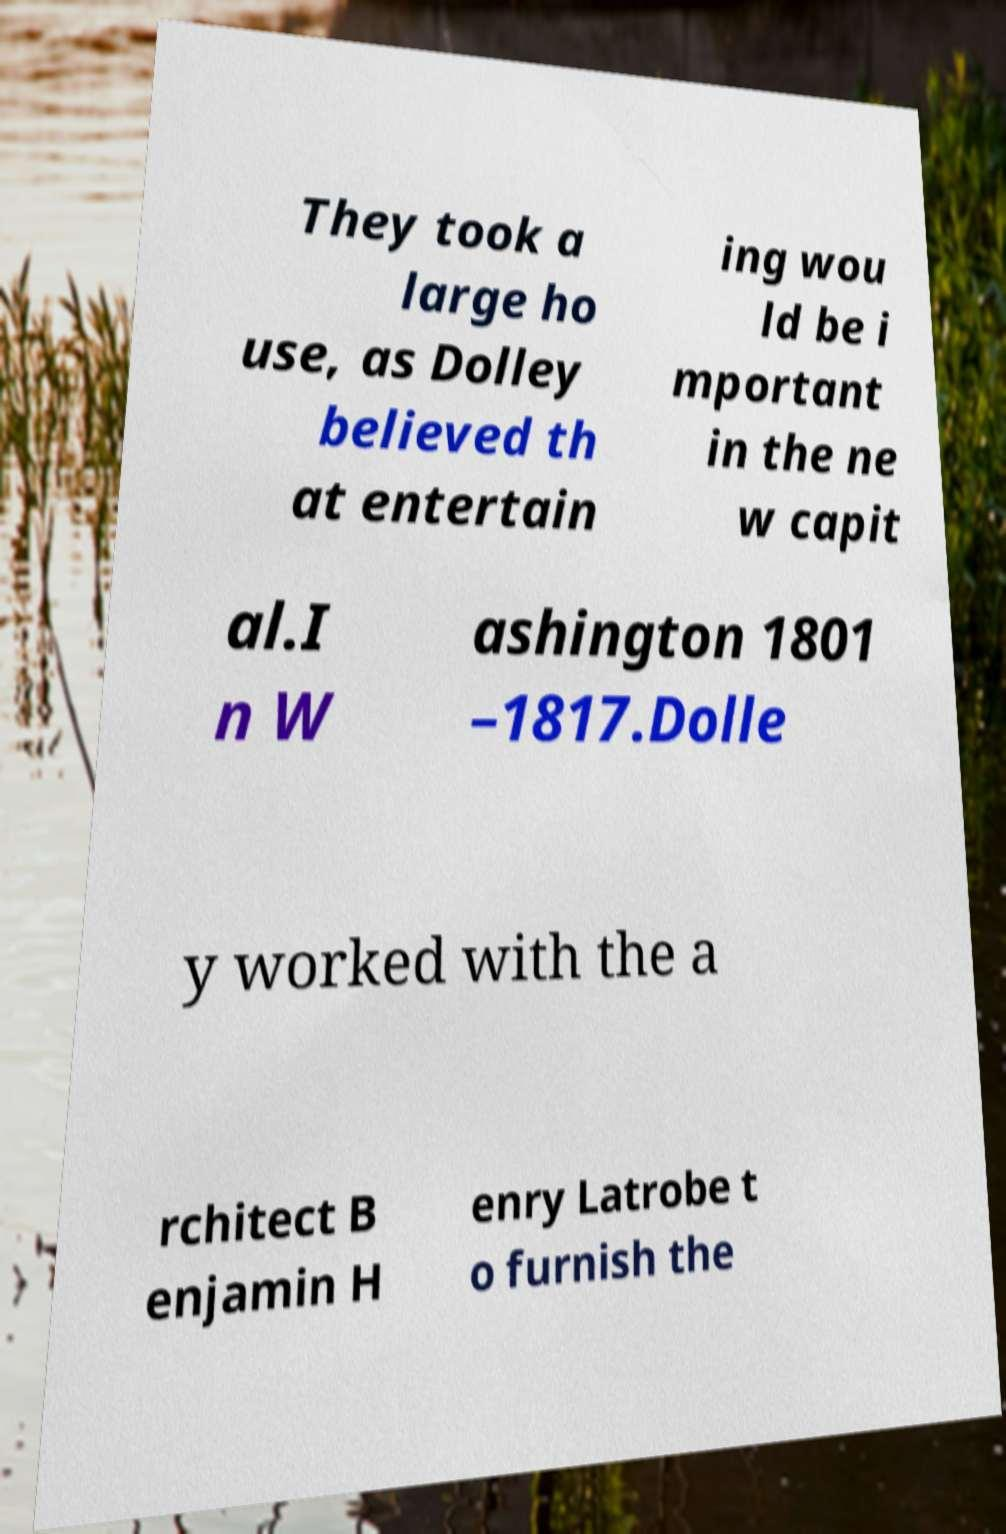Please identify and transcribe the text found in this image. They took a large ho use, as Dolley believed th at entertain ing wou ld be i mportant in the ne w capit al.I n W ashington 1801 –1817.Dolle y worked with the a rchitect B enjamin H enry Latrobe t o furnish the 